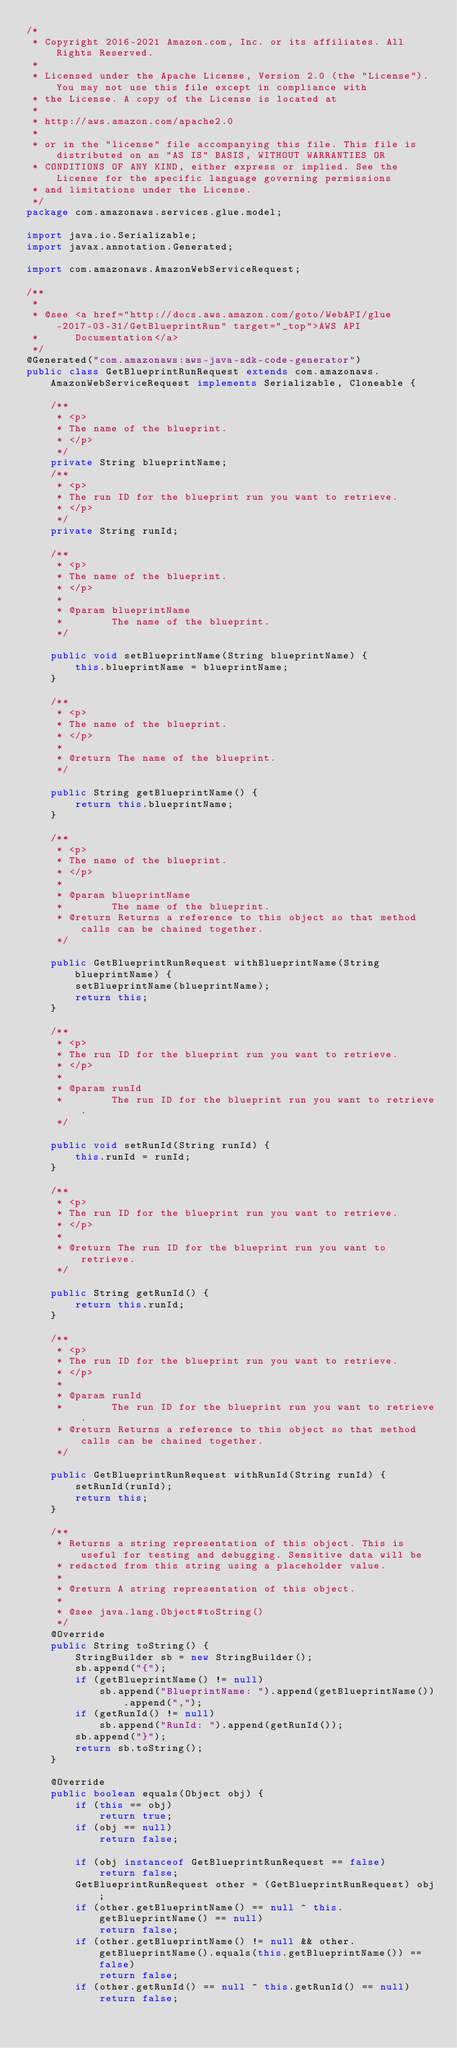<code> <loc_0><loc_0><loc_500><loc_500><_Java_>/*
 * Copyright 2016-2021 Amazon.com, Inc. or its affiliates. All Rights Reserved.
 * 
 * Licensed under the Apache License, Version 2.0 (the "License"). You may not use this file except in compliance with
 * the License. A copy of the License is located at
 * 
 * http://aws.amazon.com/apache2.0
 * 
 * or in the "license" file accompanying this file. This file is distributed on an "AS IS" BASIS, WITHOUT WARRANTIES OR
 * CONDITIONS OF ANY KIND, either express or implied. See the License for the specific language governing permissions
 * and limitations under the License.
 */
package com.amazonaws.services.glue.model;

import java.io.Serializable;
import javax.annotation.Generated;

import com.amazonaws.AmazonWebServiceRequest;

/**
 * 
 * @see <a href="http://docs.aws.amazon.com/goto/WebAPI/glue-2017-03-31/GetBlueprintRun" target="_top">AWS API
 *      Documentation</a>
 */
@Generated("com.amazonaws:aws-java-sdk-code-generator")
public class GetBlueprintRunRequest extends com.amazonaws.AmazonWebServiceRequest implements Serializable, Cloneable {

    /**
     * <p>
     * The name of the blueprint.
     * </p>
     */
    private String blueprintName;
    /**
     * <p>
     * The run ID for the blueprint run you want to retrieve.
     * </p>
     */
    private String runId;

    /**
     * <p>
     * The name of the blueprint.
     * </p>
     * 
     * @param blueprintName
     *        The name of the blueprint.
     */

    public void setBlueprintName(String blueprintName) {
        this.blueprintName = blueprintName;
    }

    /**
     * <p>
     * The name of the blueprint.
     * </p>
     * 
     * @return The name of the blueprint.
     */

    public String getBlueprintName() {
        return this.blueprintName;
    }

    /**
     * <p>
     * The name of the blueprint.
     * </p>
     * 
     * @param blueprintName
     *        The name of the blueprint.
     * @return Returns a reference to this object so that method calls can be chained together.
     */

    public GetBlueprintRunRequest withBlueprintName(String blueprintName) {
        setBlueprintName(blueprintName);
        return this;
    }

    /**
     * <p>
     * The run ID for the blueprint run you want to retrieve.
     * </p>
     * 
     * @param runId
     *        The run ID for the blueprint run you want to retrieve.
     */

    public void setRunId(String runId) {
        this.runId = runId;
    }

    /**
     * <p>
     * The run ID for the blueprint run you want to retrieve.
     * </p>
     * 
     * @return The run ID for the blueprint run you want to retrieve.
     */

    public String getRunId() {
        return this.runId;
    }

    /**
     * <p>
     * The run ID for the blueprint run you want to retrieve.
     * </p>
     * 
     * @param runId
     *        The run ID for the blueprint run you want to retrieve.
     * @return Returns a reference to this object so that method calls can be chained together.
     */

    public GetBlueprintRunRequest withRunId(String runId) {
        setRunId(runId);
        return this;
    }

    /**
     * Returns a string representation of this object. This is useful for testing and debugging. Sensitive data will be
     * redacted from this string using a placeholder value.
     *
     * @return A string representation of this object.
     *
     * @see java.lang.Object#toString()
     */
    @Override
    public String toString() {
        StringBuilder sb = new StringBuilder();
        sb.append("{");
        if (getBlueprintName() != null)
            sb.append("BlueprintName: ").append(getBlueprintName()).append(",");
        if (getRunId() != null)
            sb.append("RunId: ").append(getRunId());
        sb.append("}");
        return sb.toString();
    }

    @Override
    public boolean equals(Object obj) {
        if (this == obj)
            return true;
        if (obj == null)
            return false;

        if (obj instanceof GetBlueprintRunRequest == false)
            return false;
        GetBlueprintRunRequest other = (GetBlueprintRunRequest) obj;
        if (other.getBlueprintName() == null ^ this.getBlueprintName() == null)
            return false;
        if (other.getBlueprintName() != null && other.getBlueprintName().equals(this.getBlueprintName()) == false)
            return false;
        if (other.getRunId() == null ^ this.getRunId() == null)
            return false;</code> 